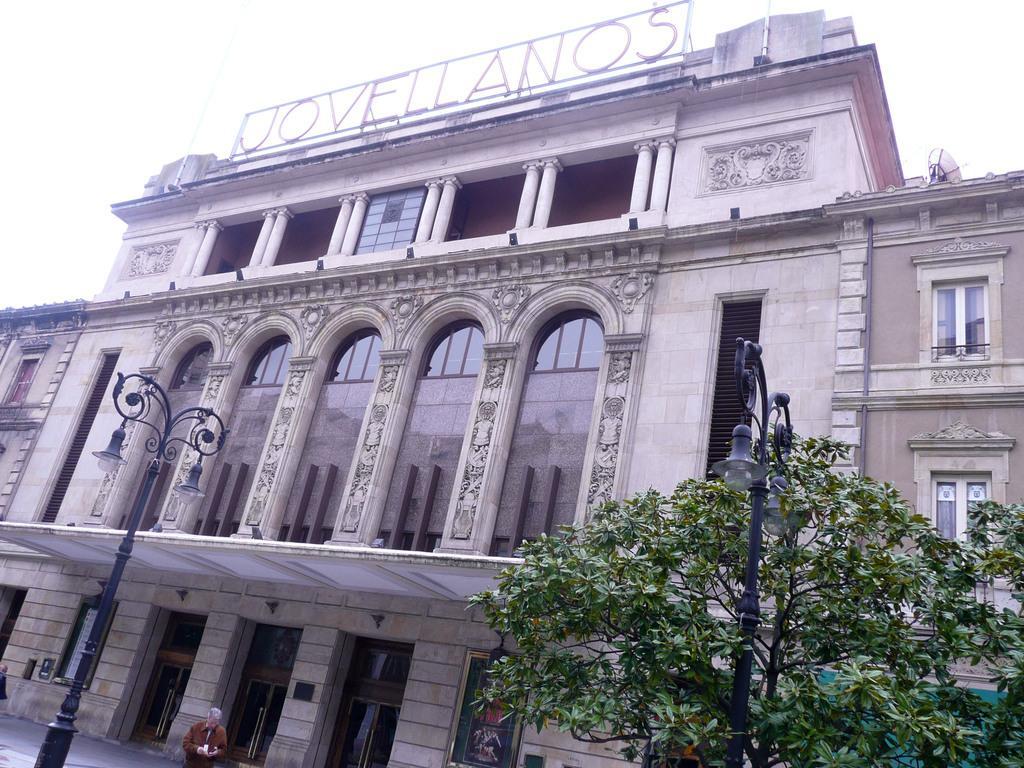Could you give a brief overview of what you see in this image? This picture might be taken from outside of the city. In this image, on the right side, we can see a tree and a street light. On the left side, we can see a street light and a man standing. In the background, we can see a building and glass window. At the top, we can see a sky. 